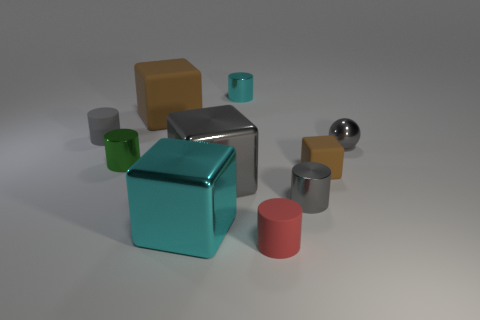The cyan metallic object that is the same shape as the green object is what size? The cyan metallic object, which shares its cubic shape with the green object, is of a medium size relative to the other objects in the image. It appears quite prominent in the scene and its size falls in between the smallest and largest items displayed. 